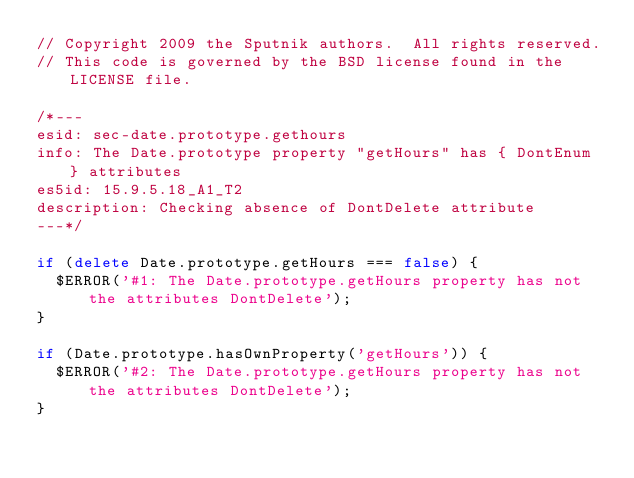<code> <loc_0><loc_0><loc_500><loc_500><_JavaScript_>// Copyright 2009 the Sputnik authors.  All rights reserved.
// This code is governed by the BSD license found in the LICENSE file.

/*---
esid: sec-date.prototype.gethours
info: The Date.prototype property "getHours" has { DontEnum } attributes
es5id: 15.9.5.18_A1_T2
description: Checking absence of DontDelete attribute
---*/

if (delete Date.prototype.getHours === false) {
  $ERROR('#1: The Date.prototype.getHours property has not the attributes DontDelete');
}

if (Date.prototype.hasOwnProperty('getHours')) {
  $ERROR('#2: The Date.prototype.getHours property has not the attributes DontDelete');
}
</code> 